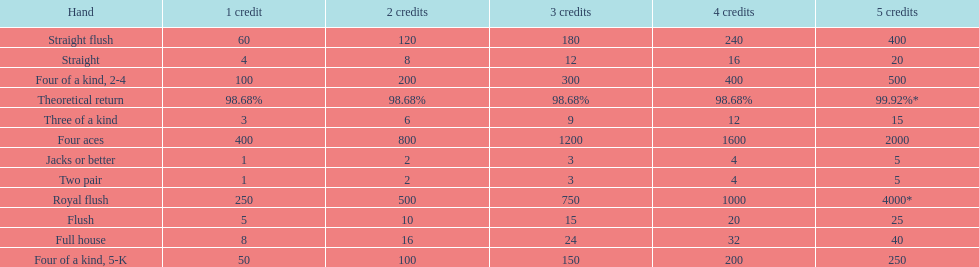At most, what could a person earn for having a full house? 40. 